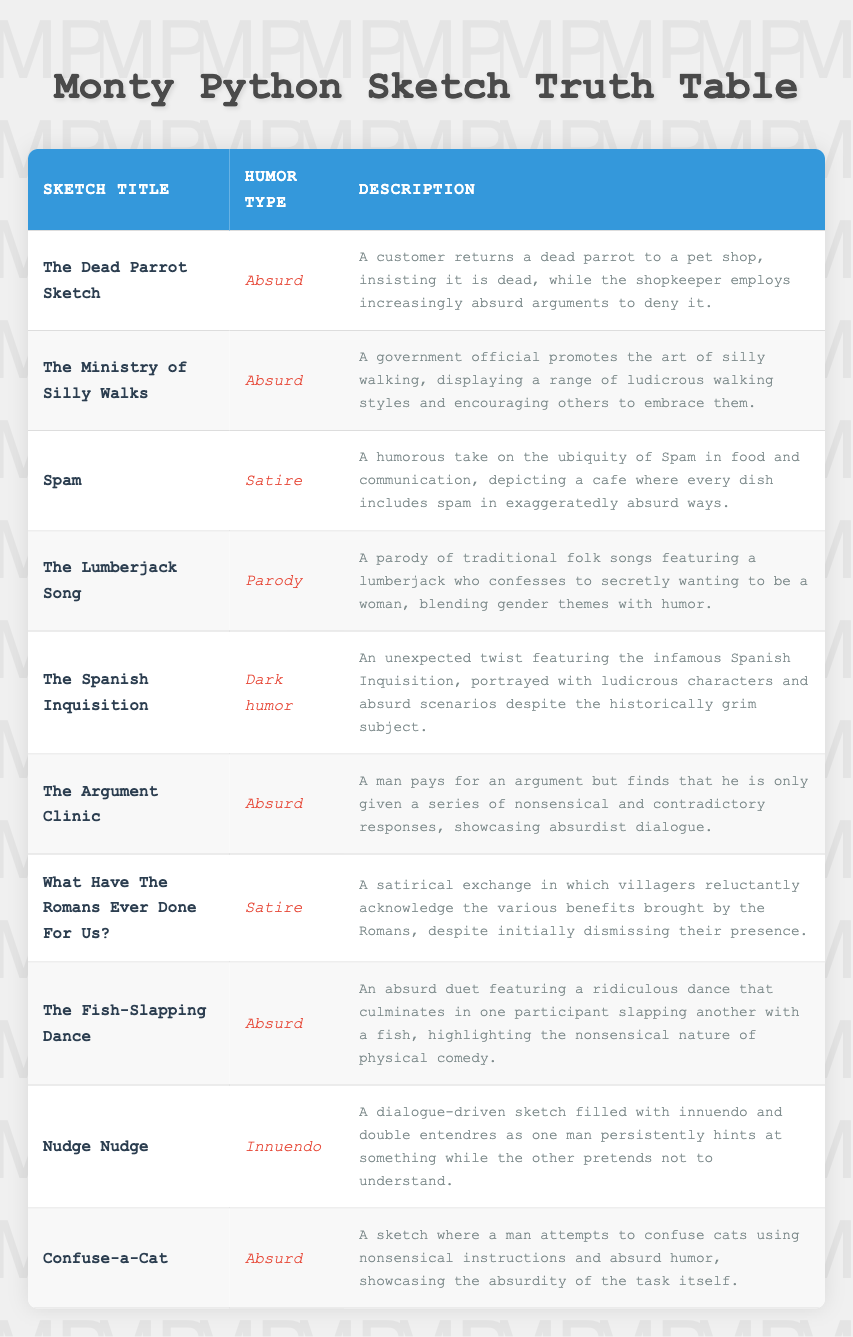What is the humor type of "The Dead Parrot Sketch"? The table indicates that "The Dead Parrot Sketch" falls under the humor type of "absurd". This information is directly available in the "Humor Type" column for the corresponding "Sketch Title".
Answer: Absurd How many sketches classified as absurd are there in total? There are 5 sketches classified as "absurd": "The Dead Parrot Sketch," "The Ministry of Silly Walks," "The Argument Clinic," "The Fish-Slapping Dance," and "Confuse-a-Cat." This is determined by counting the rows with "absurd" in the "Humor Type" column.
Answer: 5 Does "The Lumberjack Song" contain satire? No, the "Humor Type" of "The Lumberjack Song" is listed as "parody," which is different from satire. Thus, the answer is based on the explicit classification present in the table.
Answer: No Which sketch combines a lot of innuendo? The sketch titled "Nudge Nudge" is described as filled with innuendo and double entendres. This is confirmed by examining the "Description" column corresponding to that sketch.
Answer: Nudge Nudge Which humor type appears most frequently in the table? The most frequent humor type is "absurd," which appears in 5 sketches—"The Dead Parrot Sketch," "The Ministry of Silly Walks," "The Argument Clinic," "The Fish-Slapping Dance," and "Confuse-a-Cat." This is determined by tallying the occurrences in the "Humor Type" column.
Answer: Absurd What is the description of the sketch that has dark humor? The sketch "The Spanish Inquisition" is described as having an unexpected twist featuring ludicrous characters and absurd scenarios despite the historically grim subject. This unique description is found in the "Description" column corresponding to that sketch.
Answer: An unexpected twist featuring ludicrous characters and absurd scenarios despite the historically grim subject How many sketches feature satire alongside their humor type? There are 2 sketches that feature "satire": "Spam" and "What Have The Romans Ever Done For Us?". This can be determined by counting the respective occurrences under the "Humor Type" column for "satire."
Answer: 2 Is "The Fish-Slapping Dance" an example of a parody? No, "The Fish-Slapping Dance" is categorized as an "absurd" sketch, while parody is the humor type associated with "The Lumberjack Song." This information can be directly found in their respective classifications in the table.
Answer: No Which sketch uniquely combines absurdity with a physical comedy element? "The Fish-Slapping Dance" uniquely combines absurdity with physical comedy, as it involves a ridiculous dance that ends with one participant slapping another with a fish, highlighting physical humor. This is established by reviewing the sketch title and its description.
Answer: The Fish-Slapping Dance 